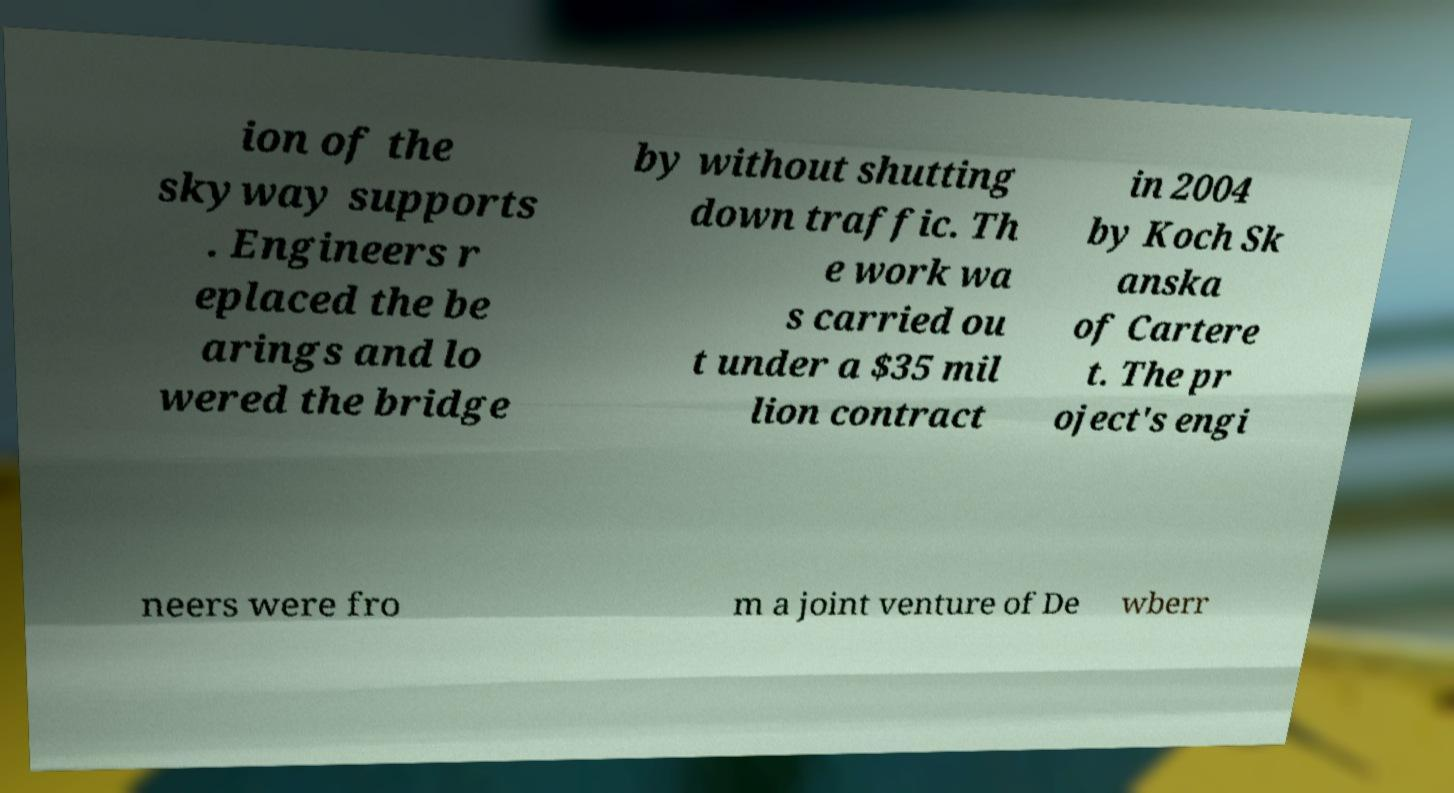Can you accurately transcribe the text from the provided image for me? ion of the skyway supports . Engineers r eplaced the be arings and lo wered the bridge by without shutting down traffic. Th e work wa s carried ou t under a $35 mil lion contract in 2004 by Koch Sk anska of Cartere t. The pr oject's engi neers were fro m a joint venture of De wberr 